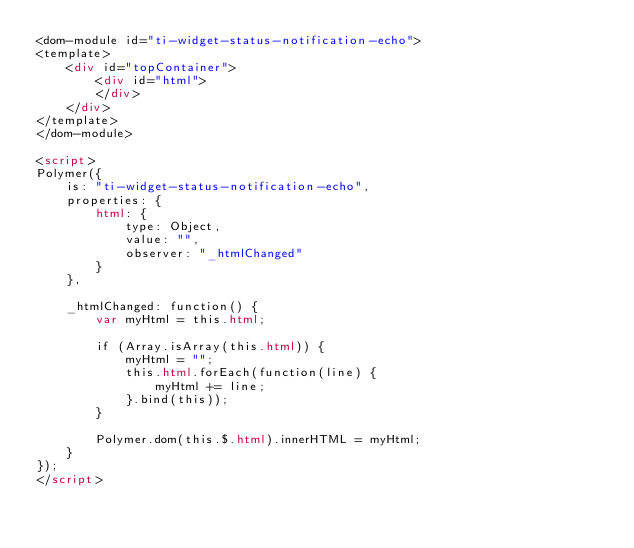<code> <loc_0><loc_0><loc_500><loc_500><_HTML_><dom-module id="ti-widget-status-notification-echo">
<template>
    <div id="topContainer">
        <div id="html">
        </div>
    </div>
</template>
</dom-module>

<script>
Polymer({
    is: "ti-widget-status-notification-echo",
    properties: {
        html: {
            type: Object,
            value: "",
            observer: "_htmlChanged"
        }
    },
    
    _htmlChanged: function() {
        var myHtml = this.html;
        
        if (Array.isArray(this.html)) {
            myHtml = "";
            this.html.forEach(function(line) {
                myHtml += line;
            }.bind(this));
        }
        
        Polymer.dom(this.$.html).innerHTML = myHtml;
    }
});
</script>
        </code> 